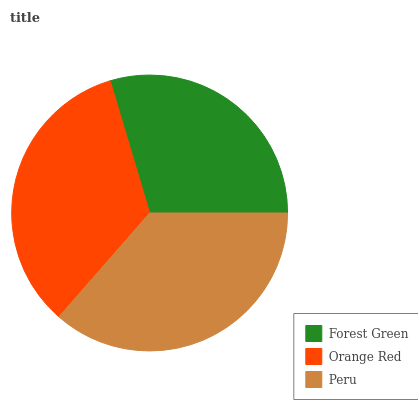Is Forest Green the minimum?
Answer yes or no. Yes. Is Peru the maximum?
Answer yes or no. Yes. Is Orange Red the minimum?
Answer yes or no. No. Is Orange Red the maximum?
Answer yes or no. No. Is Orange Red greater than Forest Green?
Answer yes or no. Yes. Is Forest Green less than Orange Red?
Answer yes or no. Yes. Is Forest Green greater than Orange Red?
Answer yes or no. No. Is Orange Red less than Forest Green?
Answer yes or no. No. Is Orange Red the high median?
Answer yes or no. Yes. Is Orange Red the low median?
Answer yes or no. Yes. Is Forest Green the high median?
Answer yes or no. No. Is Peru the low median?
Answer yes or no. No. 